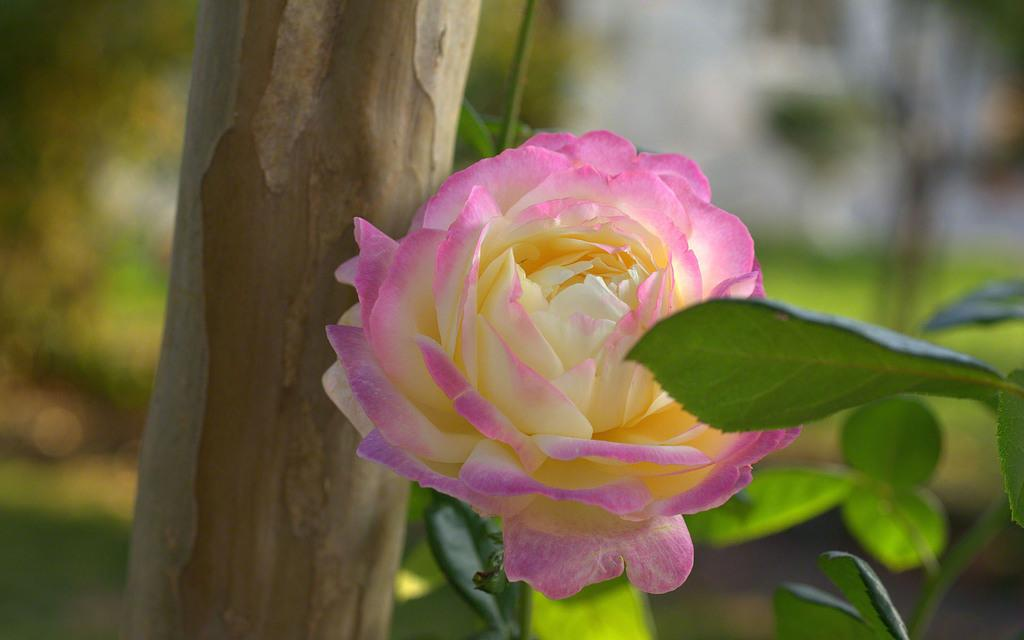What type of plant can be seen in the image? There is a flower in the image. What else is present on the plant besides the flower? There are leaves in the image. What material is the wooden object made of? The wooden object in the image is made of wood. How would you describe the background of the image? The background of the image is blurred. How many toes are visible in the image? There are no toes visible in the image. What order is the flower classified under in the image? The image does not provide enough information to classify the flower under a specific order. 